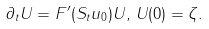<formula> <loc_0><loc_0><loc_500><loc_500>\partial _ { t } U = F ^ { \prime } ( S _ { t } u _ { 0 } ) U , \, U ( 0 ) = \zeta .</formula> 